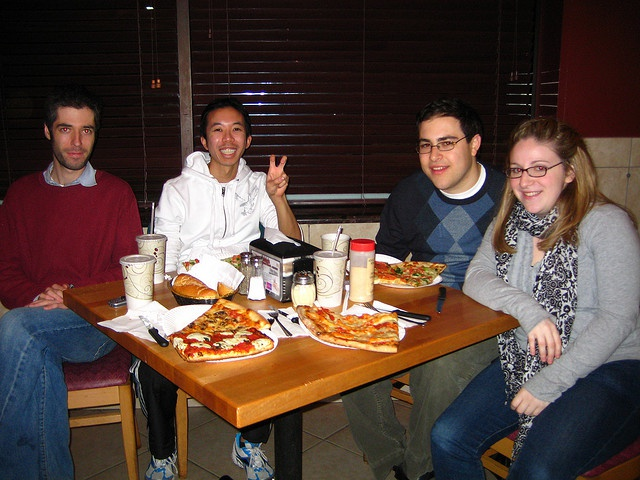Describe the objects in this image and their specific colors. I can see dining table in black, brown, ivory, and maroon tones, people in black, darkgray, gray, and lightpink tones, people in black, maroon, navy, and blue tones, people in black, gray, and blue tones, and people in black, white, and brown tones in this image. 